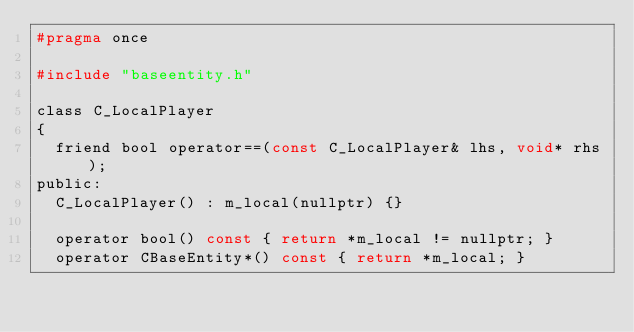Convert code to text. <code><loc_0><loc_0><loc_500><loc_500><_C_>#pragma once

#include "baseentity.h"

class C_LocalPlayer
{
	friend bool operator==(const C_LocalPlayer& lhs, void* rhs);
public:
	C_LocalPlayer() : m_local(nullptr) {}

	operator bool() const { return *m_local != nullptr; }
	operator CBaseEntity*() const { return *m_local; }
</code> 